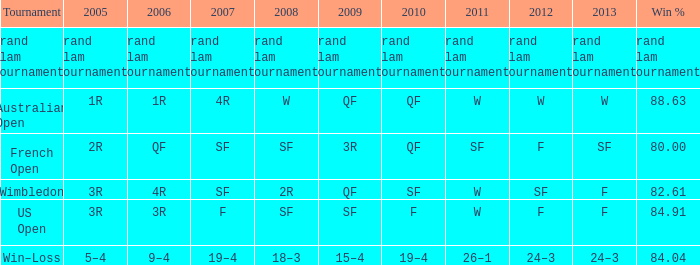What in 2005 has a victory percentage of 8 3R. 